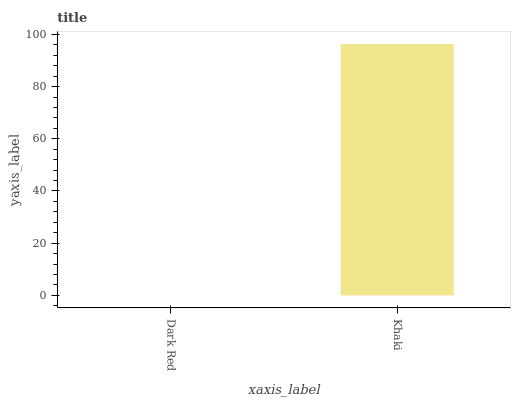Is Khaki the minimum?
Answer yes or no. No. Is Khaki greater than Dark Red?
Answer yes or no. Yes. Is Dark Red less than Khaki?
Answer yes or no. Yes. Is Dark Red greater than Khaki?
Answer yes or no. No. Is Khaki less than Dark Red?
Answer yes or no. No. Is Khaki the high median?
Answer yes or no. Yes. Is Dark Red the low median?
Answer yes or no. Yes. Is Dark Red the high median?
Answer yes or no. No. Is Khaki the low median?
Answer yes or no. No. 